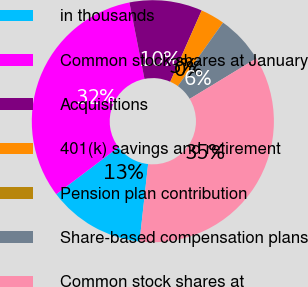Convert chart. <chart><loc_0><loc_0><loc_500><loc_500><pie_chart><fcel>in thousands<fcel>Common stock shares at January<fcel>Acquisitions<fcel>401(k) savings and retirement<fcel>Pension plan contribution<fcel>Share-based compensation plans<fcel>Common stock shares at<nl><fcel>12.95%<fcel>32.2%<fcel>9.71%<fcel>3.24%<fcel>0.0%<fcel>6.47%<fcel>35.43%<nl></chart> 